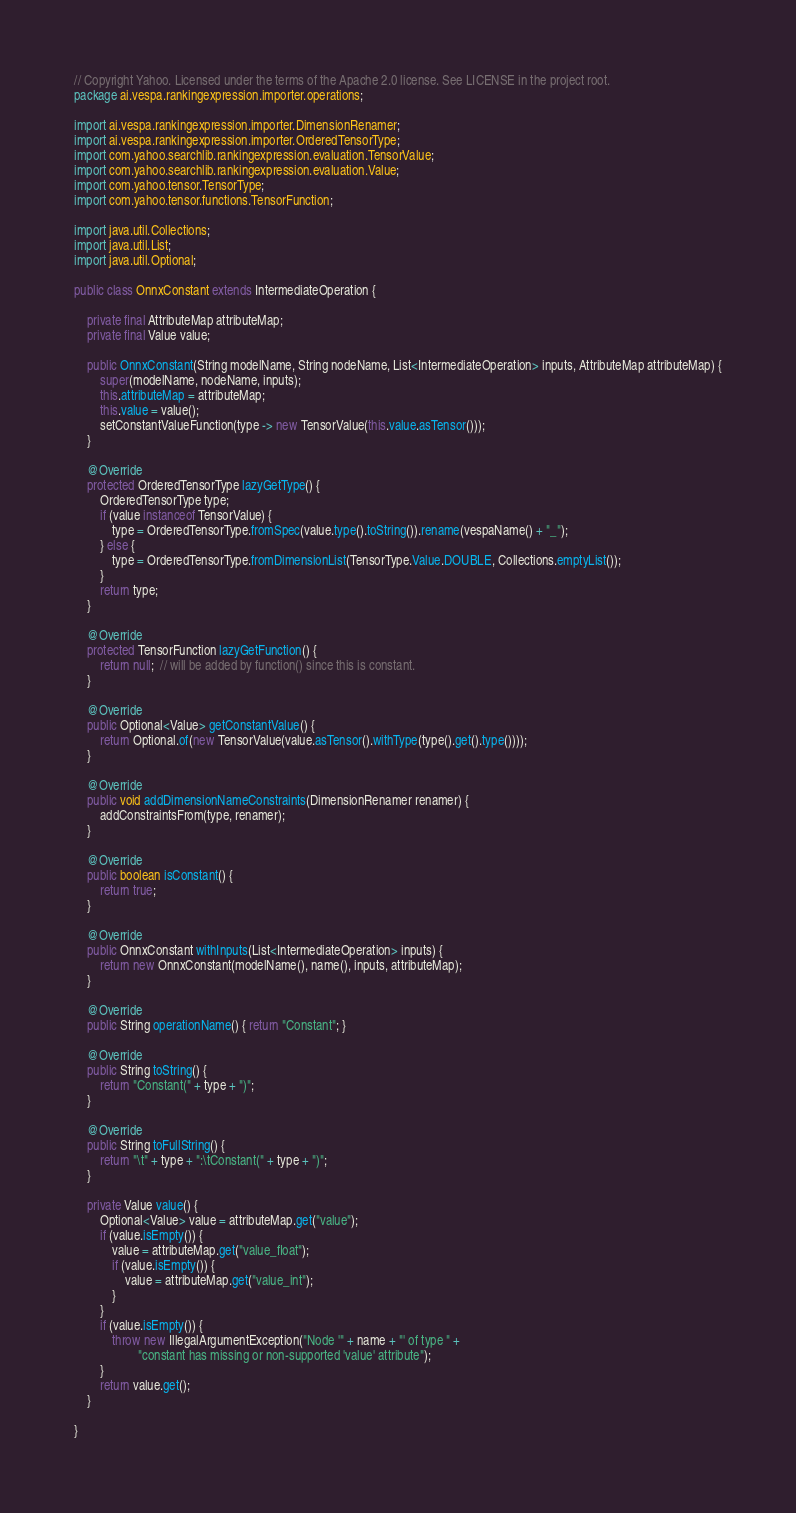<code> <loc_0><loc_0><loc_500><loc_500><_Java_>// Copyright Yahoo. Licensed under the terms of the Apache 2.0 license. See LICENSE in the project root.
package ai.vespa.rankingexpression.importer.operations;

import ai.vespa.rankingexpression.importer.DimensionRenamer;
import ai.vespa.rankingexpression.importer.OrderedTensorType;
import com.yahoo.searchlib.rankingexpression.evaluation.TensorValue;
import com.yahoo.searchlib.rankingexpression.evaluation.Value;
import com.yahoo.tensor.TensorType;
import com.yahoo.tensor.functions.TensorFunction;

import java.util.Collections;
import java.util.List;
import java.util.Optional;

public class OnnxConstant extends IntermediateOperation {

    private final AttributeMap attributeMap;
    private final Value value;

    public OnnxConstant(String modelName, String nodeName, List<IntermediateOperation> inputs, AttributeMap attributeMap) {
        super(modelName, nodeName, inputs);
        this.attributeMap = attributeMap;
        this.value = value();
        setConstantValueFunction(type -> new TensorValue(this.value.asTensor()));
    }

    @Override
    protected OrderedTensorType lazyGetType() {
        OrderedTensorType type;
        if (value instanceof TensorValue) {
            type = OrderedTensorType.fromSpec(value.type().toString()).rename(vespaName() + "_");
        } else {
            type = OrderedTensorType.fromDimensionList(TensorType.Value.DOUBLE, Collections.emptyList());
        }
        return type;
    }

    @Override
    protected TensorFunction lazyGetFunction() {
        return null;  // will be added by function() since this is constant.
    }

    @Override
    public Optional<Value> getConstantValue() {
        return Optional.of(new TensorValue(value.asTensor().withType(type().get().type())));
    }

    @Override
    public void addDimensionNameConstraints(DimensionRenamer renamer) {
        addConstraintsFrom(type, renamer);
    }

    @Override
    public boolean isConstant() {
        return true;
    }

    @Override
    public OnnxConstant withInputs(List<IntermediateOperation> inputs) {
        return new OnnxConstant(modelName(), name(), inputs, attributeMap);
    }

    @Override
    public String operationName() { return "Constant"; }

    @Override
    public String toString() {
        return "Constant(" + type + ")";
    }

    @Override
    public String toFullString() {
        return "\t" + type + ":\tConstant(" + type + ")";
    }

    private Value value() {
        Optional<Value> value = attributeMap.get("value");
        if (value.isEmpty()) {
            value = attributeMap.get("value_float");
            if (value.isEmpty()) {
                value = attributeMap.get("value_int");
            }
        }
        if (value.isEmpty()) {
            throw new IllegalArgumentException("Node '" + name + "' of type " +
                    "constant has missing or non-supported 'value' attribute");
        }
        return value.get();
    }

}
</code> 